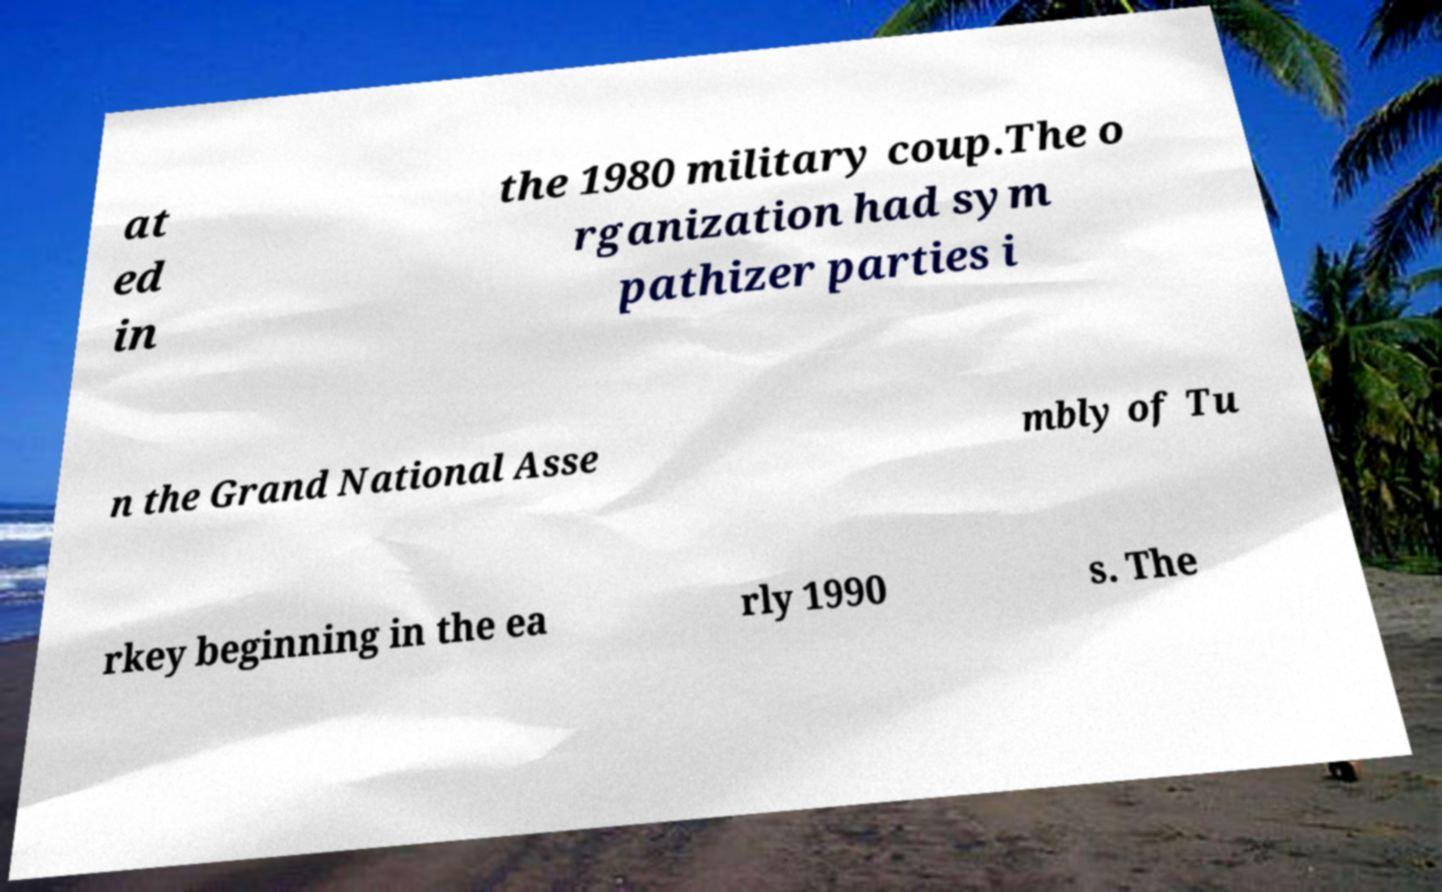Can you accurately transcribe the text from the provided image for me? at ed in the 1980 military coup.The o rganization had sym pathizer parties i n the Grand National Asse mbly of Tu rkey beginning in the ea rly 1990 s. The 